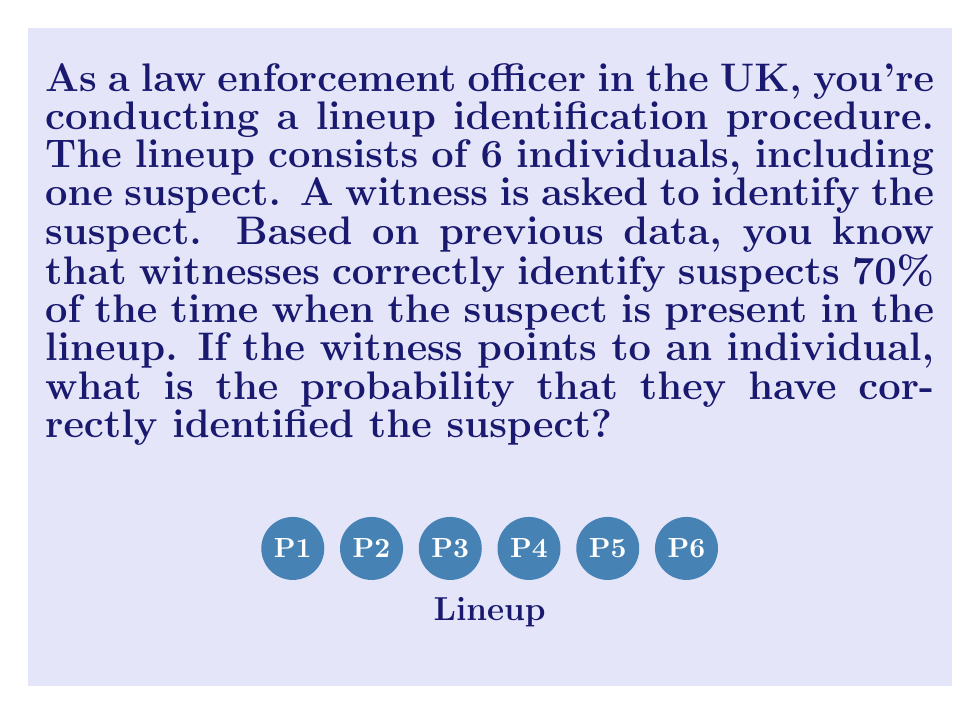Can you answer this question? Let's approach this step-by-step using Bayes' theorem:

1) Let's define our events:
   A: The witness points to the suspect
   B: The identification is correct

2) We're given P(A|B) = 0.7 (70% correct identification when suspect is present)

3) We need to find P(B|A) (probability of correct identification given that the witness pointed to someone)

4) Bayes' theorem states:

   $$P(B|A) = \frac{P(A|B) \cdot P(B)}{P(A)}$$

5) We know P(A|B) = 0.7

6) P(B) is the probability that the suspect is the person pointed to, which is 1/6 (as there are 6 people in the lineup)

7) P(A) can be calculated using the law of total probability:
   
   $$P(A) = P(A|B) \cdot P(B) + P(A|not B) \cdot P(not B)$$

8) P(A|not B) is the probability of pointing to someone when it's not the suspect. We can assume this is evenly distributed among the remaining 5 people, so it's 1/5.

9) P(not B) = 1 - P(B) = 5/6

10) Plugging into the formula from step 7:

    $$P(A) = 0.7 \cdot \frac{1}{6} + \frac{1}{5} \cdot \frac{5}{6} = \frac{7}{60} + \frac{1}{6} = \frac{7}{60} + \frac{10}{60} = \frac{17}{60}$$

11) Now we can use Bayes' theorem:

    $$P(B|A) = \frac{0.7 \cdot \frac{1}{6}}{\frac{17}{60}} = \frac{0.7 \cdot \frac{10}{60}}{\frac{17}{60}} = \frac{7}{17} \approx 0.4118$$

Therefore, the probability that the witness has correctly identified the suspect is approximately 0.4118 or 41.18%.
Answer: $\frac{7}{17} \approx 0.4118$ or 41.18% 